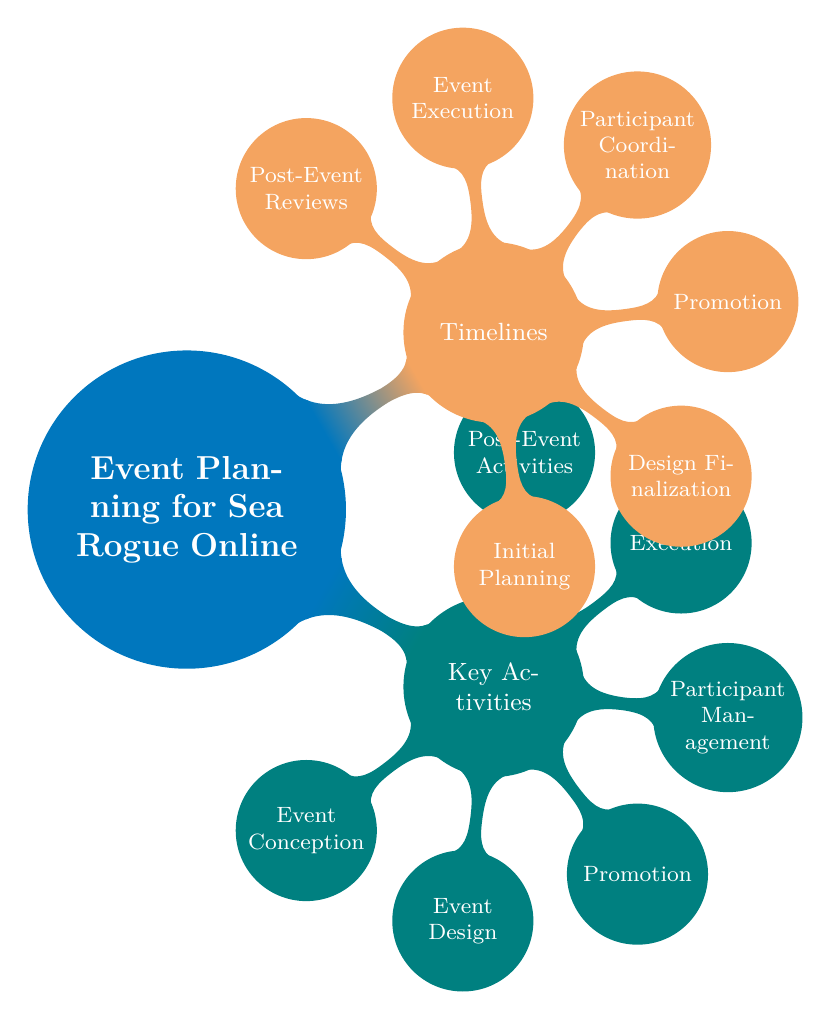What are the key activities in the event planning process? The diagram lists six key activities under "Key Activities": Event Conception, Event Design, Promotion, Participant Management, Execution, and Post-Event Activities.
Answer: Event Conception, Event Design, Promotion, Participant Management, Execution, Post-Event Activities How many nodes are in the "Timelines" section? The "Timelines" section contains six nodes: Initial Planning, Design Finalization, Promotion, Participant Coordination, Event Execution, and Post-Event Reviews. Counting these provides the answer.
Answer: 6 What is the timeline for the Promotion activity? The timeline for Promotion, as indicated in the Timelines section, is three weeks before the event. This can be found directly under the Promotion node in the Timelines section.
Answer: 3 Weeks Before What comes before Participant Coordination in the timeline? The timeline indicates that Participant Coordination follows after Promotion, which is scheduled for three weeks before the event. Therefore, Promotion is the activity that comes before it in the timeline.
Answer: Promotion Which activity involves feedback collection? Feedback Collection is listed under "Participant Management" in the "Key Activities" section of the diagram. This allows us to directly trace which activity it is connected to.
Answer: Participant Management What is the relationship between Event Execution and Post-Event Reviews? Event Execution occurs on the Event Day and is followed by Post-Event Reviews, which take place one week after the event. This describes a sequential relationship where Post-Event Reviews depend on the completion of Event Execution.
Answer: Sequential Relationship 